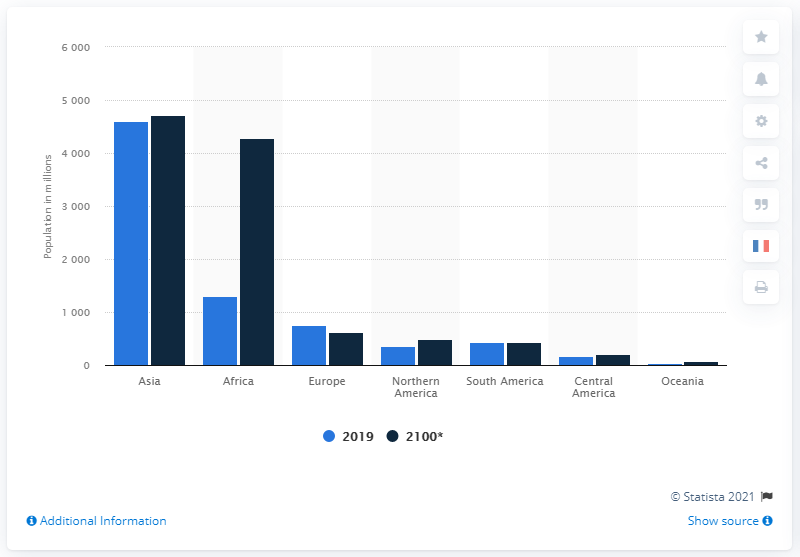Mention a couple of crucial points in this snapshot. The population of Asia in 2019 was 4601.37... According to projections, the population of Asia is expected to reach 4,719.42 million in the year 2100. 